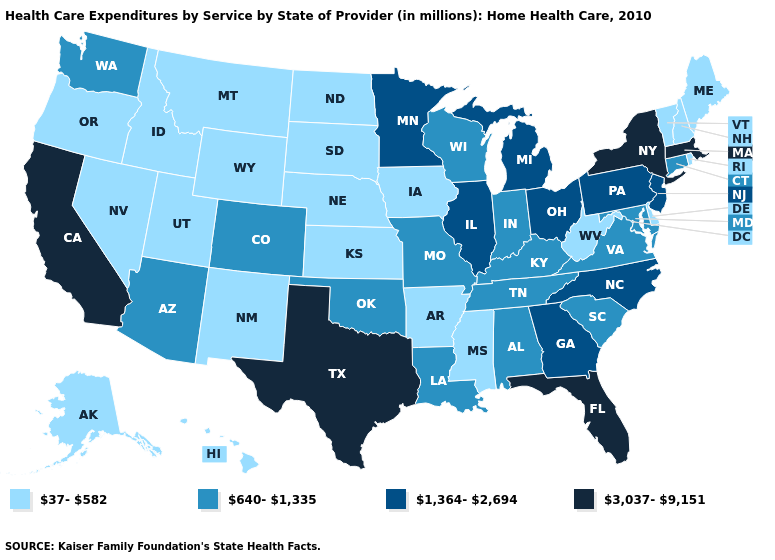Name the states that have a value in the range 640-1,335?
Quick response, please. Alabama, Arizona, Colorado, Connecticut, Indiana, Kentucky, Louisiana, Maryland, Missouri, Oklahoma, South Carolina, Tennessee, Virginia, Washington, Wisconsin. What is the lowest value in the MidWest?
Short answer required. 37-582. What is the lowest value in the USA?
Answer briefly. 37-582. Does Hawaii have the lowest value in the USA?
Quick response, please. Yes. Name the states that have a value in the range 37-582?
Short answer required. Alaska, Arkansas, Delaware, Hawaii, Idaho, Iowa, Kansas, Maine, Mississippi, Montana, Nebraska, Nevada, New Hampshire, New Mexico, North Dakota, Oregon, Rhode Island, South Dakota, Utah, Vermont, West Virginia, Wyoming. How many symbols are there in the legend?
Write a very short answer. 4. What is the lowest value in states that border Arkansas?
Answer briefly. 37-582. Among the states that border South Dakota , which have the highest value?
Give a very brief answer. Minnesota. Does Missouri have a lower value than Georgia?
Write a very short answer. Yes. Does Mississippi have the lowest value in the South?
Write a very short answer. Yes. Does the map have missing data?
Answer briefly. No. Name the states that have a value in the range 3,037-9,151?
Give a very brief answer. California, Florida, Massachusetts, New York, Texas. Name the states that have a value in the range 3,037-9,151?
Give a very brief answer. California, Florida, Massachusetts, New York, Texas. Name the states that have a value in the range 37-582?
Give a very brief answer. Alaska, Arkansas, Delaware, Hawaii, Idaho, Iowa, Kansas, Maine, Mississippi, Montana, Nebraska, Nevada, New Hampshire, New Mexico, North Dakota, Oregon, Rhode Island, South Dakota, Utah, Vermont, West Virginia, Wyoming. 